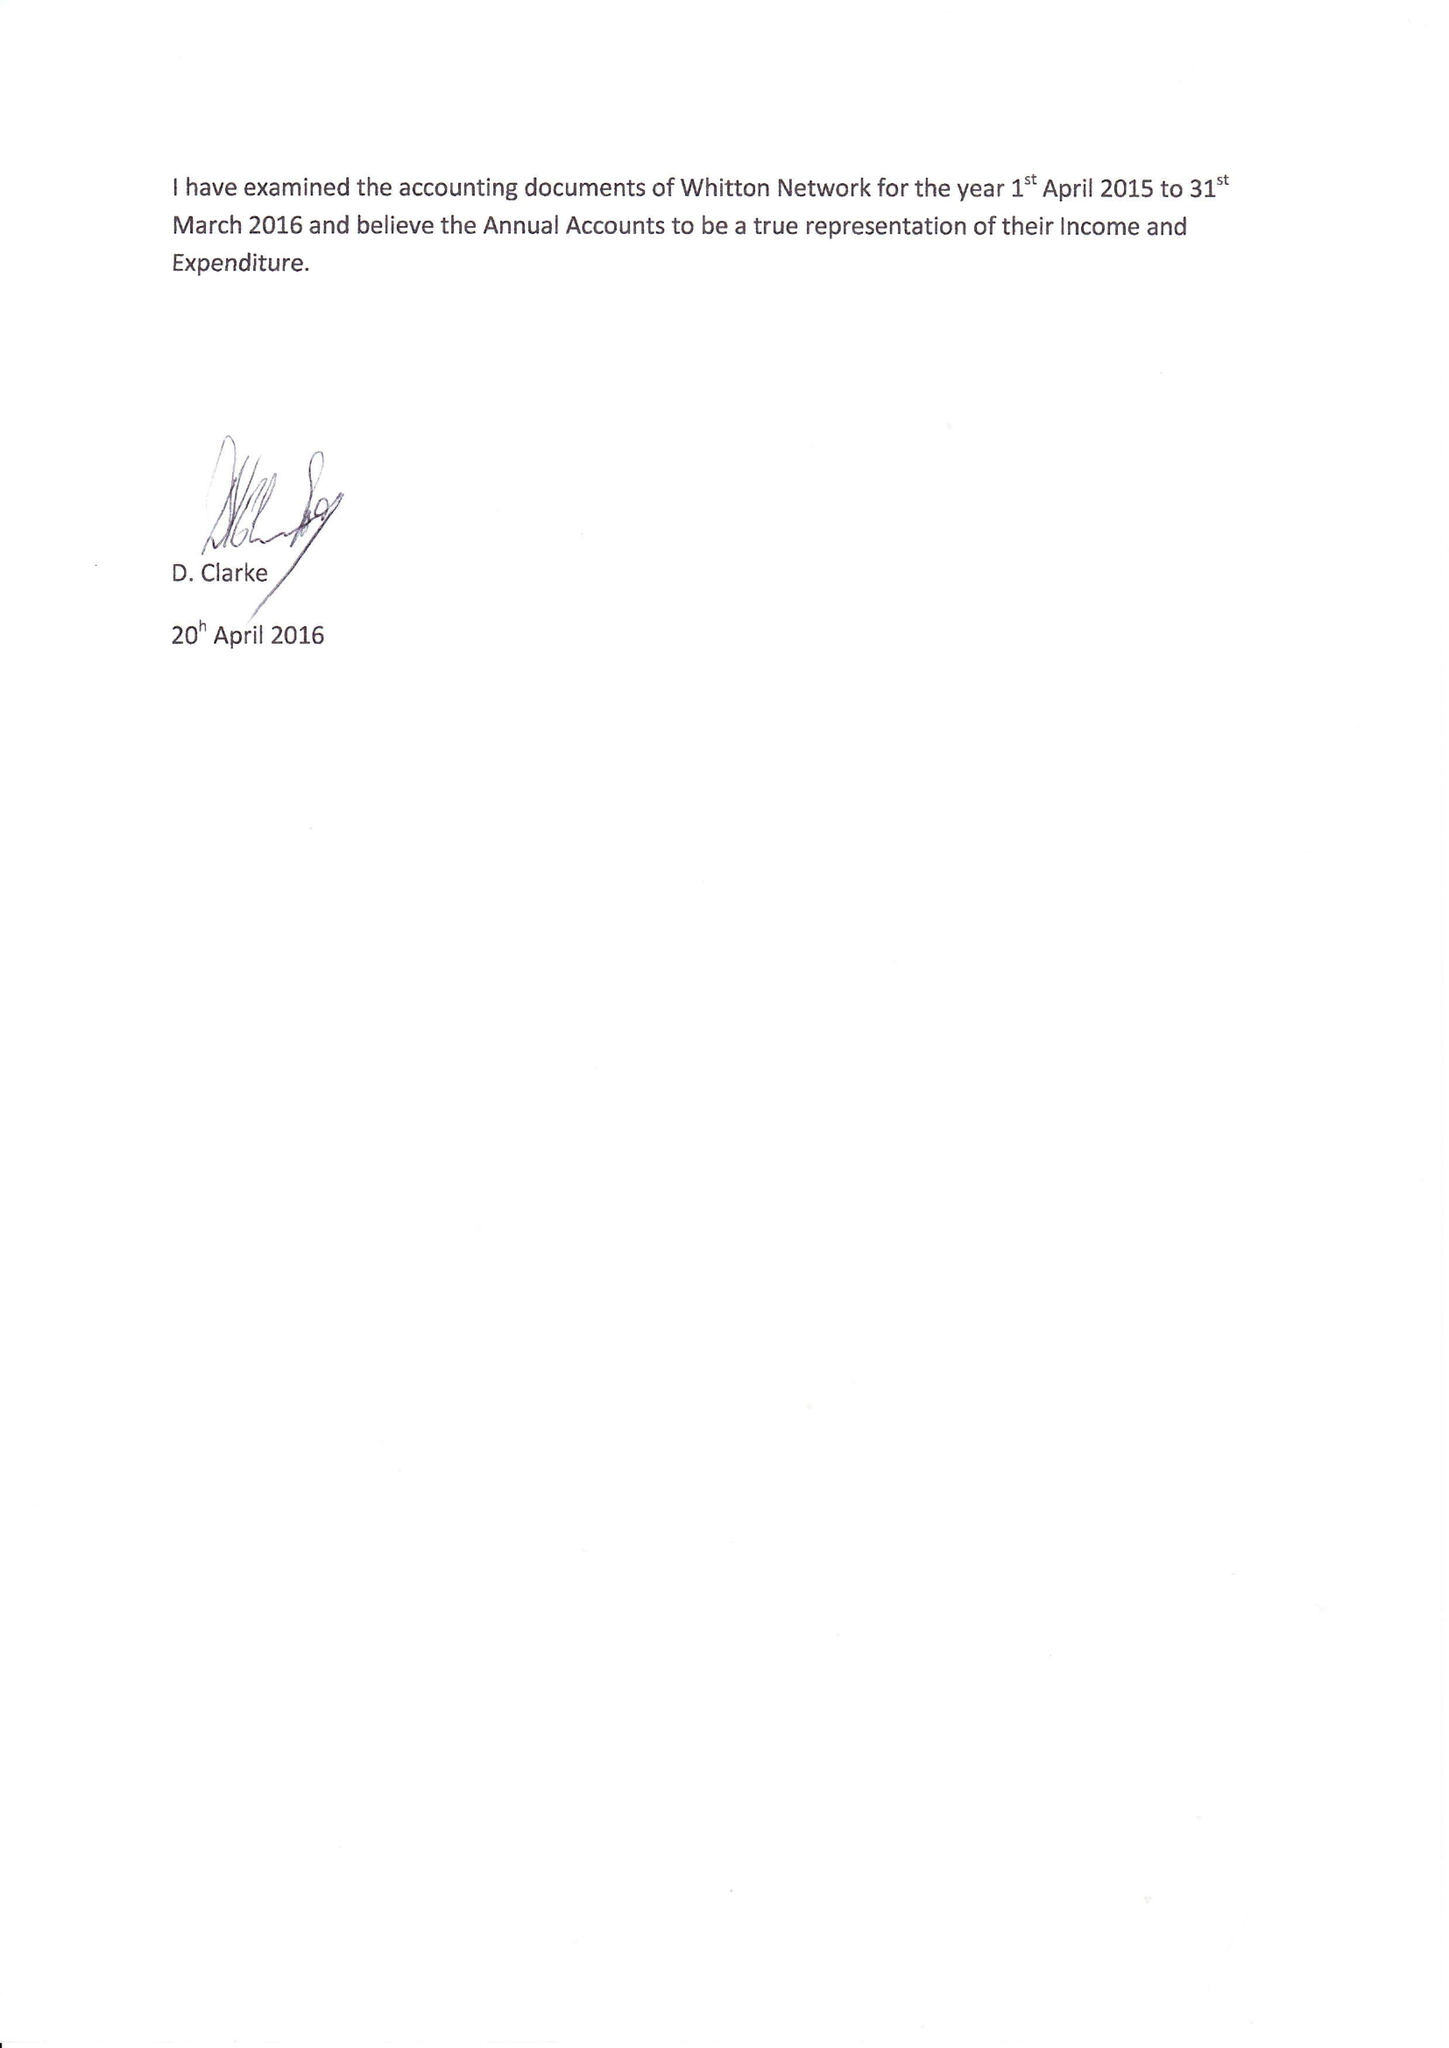What is the value for the income_annually_in_british_pounds?
Answer the question using a single word or phrase. 26292.00 